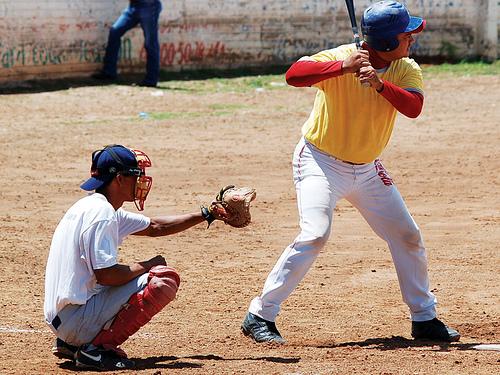What color is the grass?
Answer briefly. Green. Is grass on the field?
Short answer required. No. What color is the batters shirt?
Quick response, please. Yellow. Is the mans shirt print or a solid color?
Short answer required. Solid. 